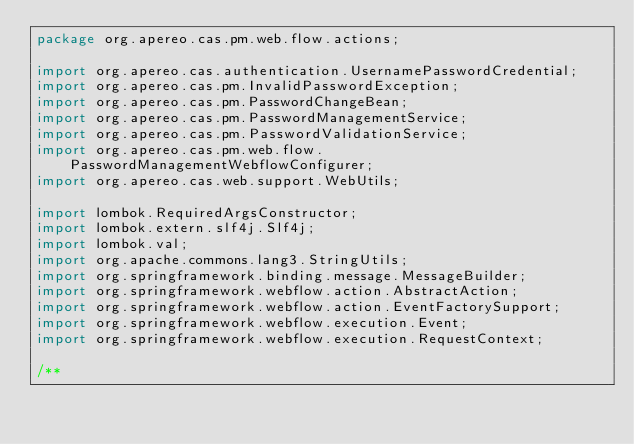Convert code to text. <code><loc_0><loc_0><loc_500><loc_500><_Java_>package org.apereo.cas.pm.web.flow.actions;

import org.apereo.cas.authentication.UsernamePasswordCredential;
import org.apereo.cas.pm.InvalidPasswordException;
import org.apereo.cas.pm.PasswordChangeBean;
import org.apereo.cas.pm.PasswordManagementService;
import org.apereo.cas.pm.PasswordValidationService;
import org.apereo.cas.pm.web.flow.PasswordManagementWebflowConfigurer;
import org.apereo.cas.web.support.WebUtils;

import lombok.RequiredArgsConstructor;
import lombok.extern.slf4j.Slf4j;
import lombok.val;
import org.apache.commons.lang3.StringUtils;
import org.springframework.binding.message.MessageBuilder;
import org.springframework.webflow.action.AbstractAction;
import org.springframework.webflow.action.EventFactorySupport;
import org.springframework.webflow.execution.Event;
import org.springframework.webflow.execution.RequestContext;

/**</code> 